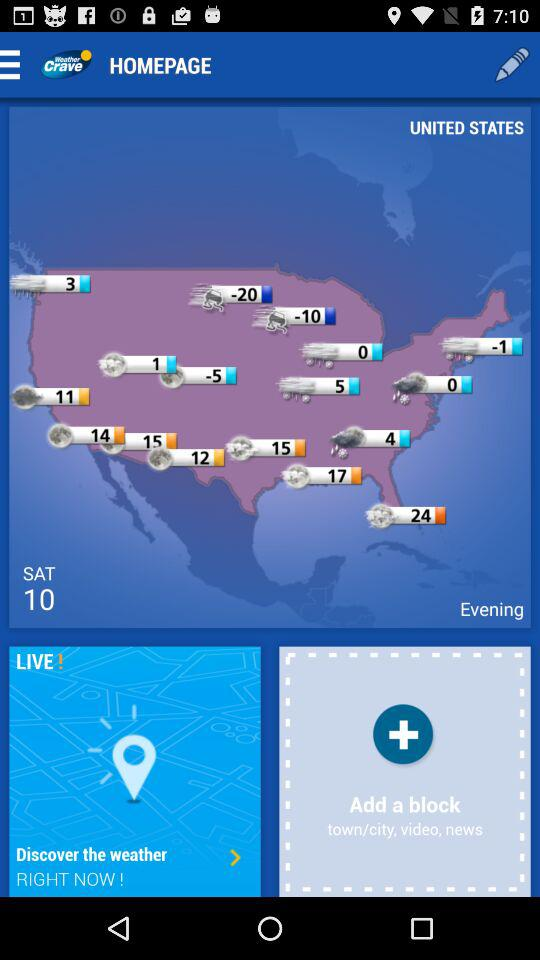What is the day and date? It is Saturday, 10. 